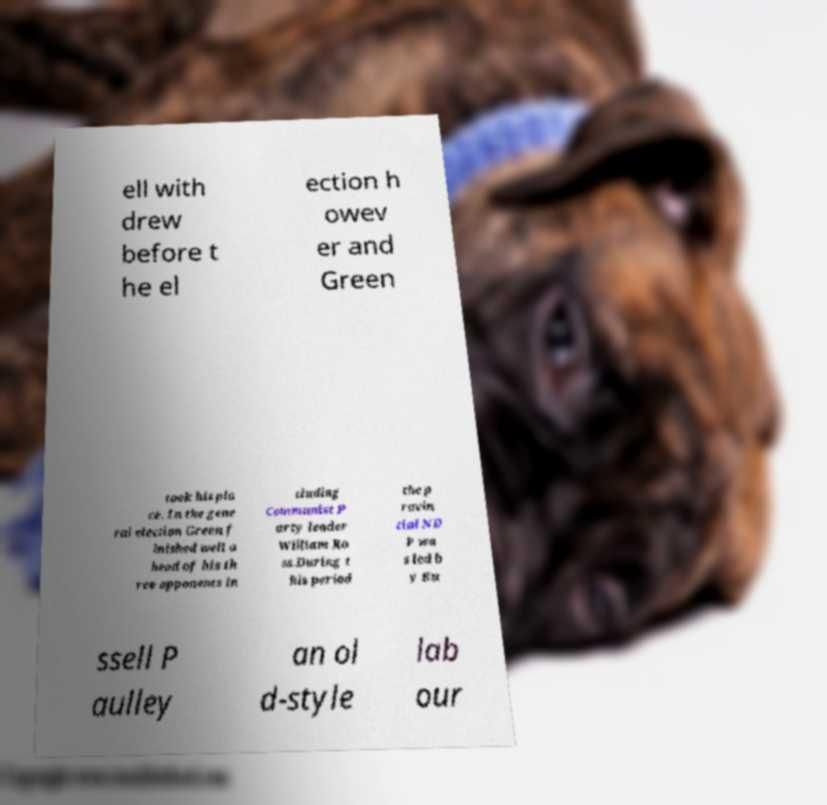What messages or text are displayed in this image? I need them in a readable, typed format. ell with drew before t he el ection h owev er and Green took his pla ce. In the gene ral election Green f inished well a head of his th ree opponents in cluding Communist P arty leader William Ro ss.During t his period the p rovin cial ND P wa s led b y Ru ssell P aulley an ol d-style lab our 